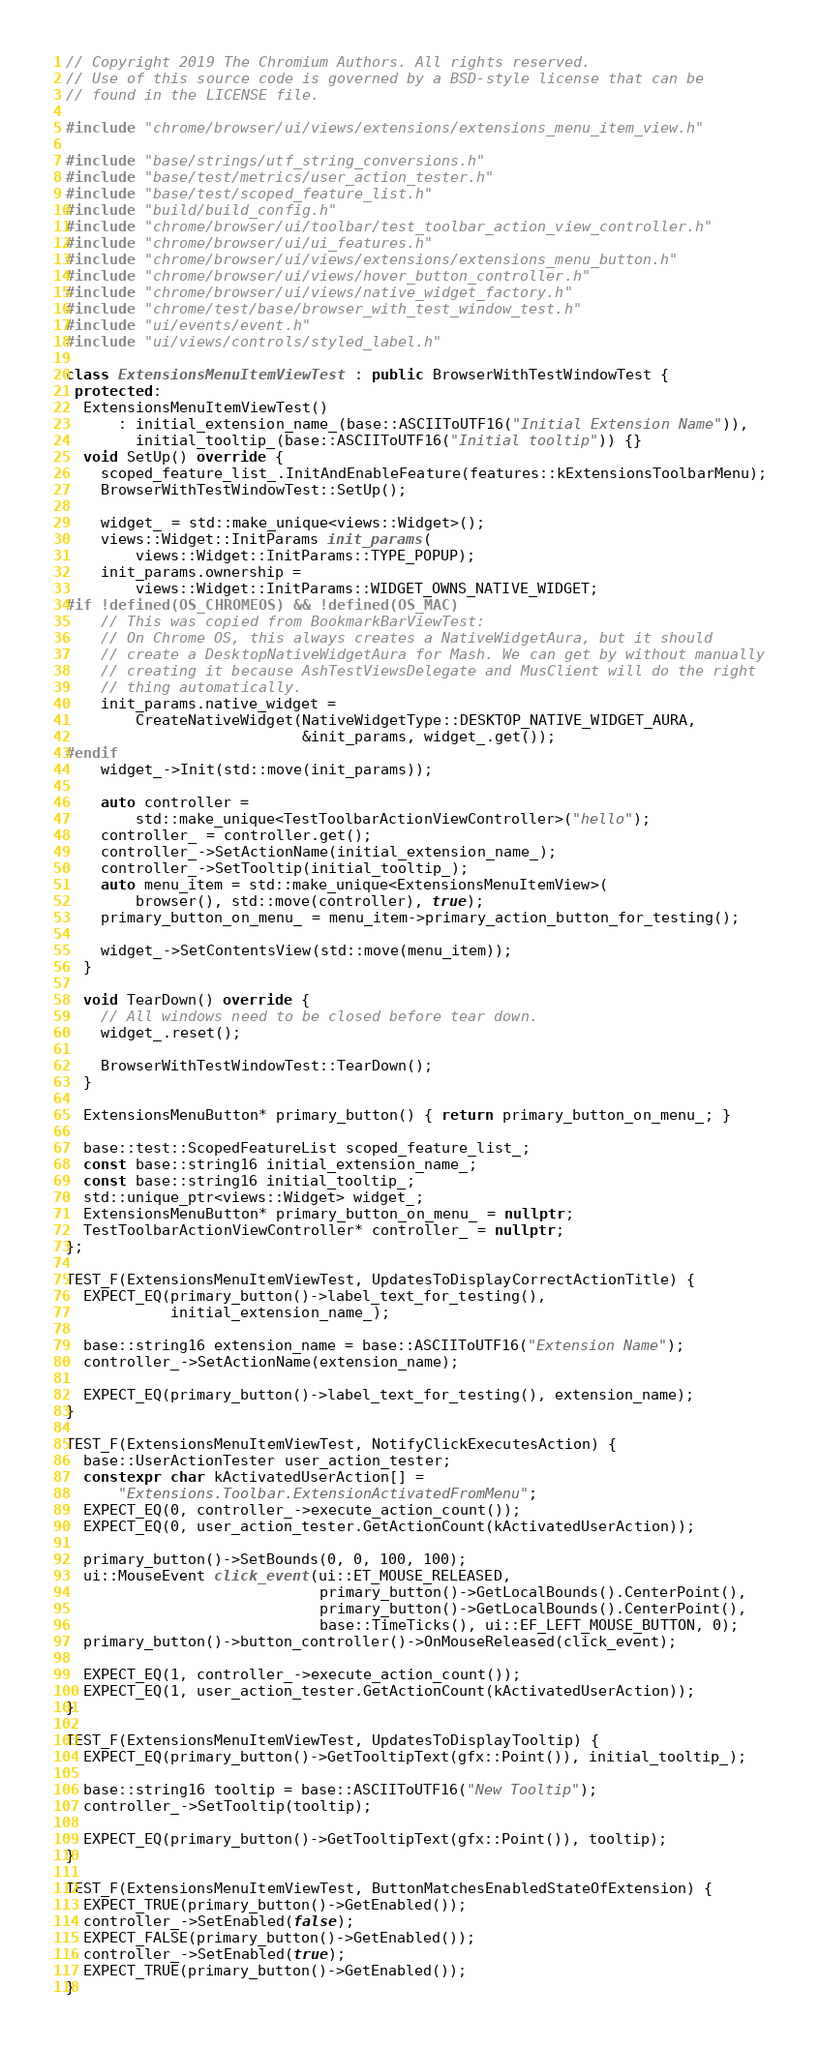<code> <loc_0><loc_0><loc_500><loc_500><_C++_>// Copyright 2019 The Chromium Authors. All rights reserved.
// Use of this source code is governed by a BSD-style license that can be
// found in the LICENSE file.

#include "chrome/browser/ui/views/extensions/extensions_menu_item_view.h"

#include "base/strings/utf_string_conversions.h"
#include "base/test/metrics/user_action_tester.h"
#include "base/test/scoped_feature_list.h"
#include "build/build_config.h"
#include "chrome/browser/ui/toolbar/test_toolbar_action_view_controller.h"
#include "chrome/browser/ui/ui_features.h"
#include "chrome/browser/ui/views/extensions/extensions_menu_button.h"
#include "chrome/browser/ui/views/hover_button_controller.h"
#include "chrome/browser/ui/views/native_widget_factory.h"
#include "chrome/test/base/browser_with_test_window_test.h"
#include "ui/events/event.h"
#include "ui/views/controls/styled_label.h"

class ExtensionsMenuItemViewTest : public BrowserWithTestWindowTest {
 protected:
  ExtensionsMenuItemViewTest()
      : initial_extension_name_(base::ASCIIToUTF16("Initial Extension Name")),
        initial_tooltip_(base::ASCIIToUTF16("Initial tooltip")) {}
  void SetUp() override {
    scoped_feature_list_.InitAndEnableFeature(features::kExtensionsToolbarMenu);
    BrowserWithTestWindowTest::SetUp();

    widget_ = std::make_unique<views::Widget>();
    views::Widget::InitParams init_params(
        views::Widget::InitParams::TYPE_POPUP);
    init_params.ownership =
        views::Widget::InitParams::WIDGET_OWNS_NATIVE_WIDGET;
#if !defined(OS_CHROMEOS) && !defined(OS_MAC)
    // This was copied from BookmarkBarViewTest:
    // On Chrome OS, this always creates a NativeWidgetAura, but it should
    // create a DesktopNativeWidgetAura for Mash. We can get by without manually
    // creating it because AshTestViewsDelegate and MusClient will do the right
    // thing automatically.
    init_params.native_widget =
        CreateNativeWidget(NativeWidgetType::DESKTOP_NATIVE_WIDGET_AURA,
                           &init_params, widget_.get());
#endif
    widget_->Init(std::move(init_params));

    auto controller =
        std::make_unique<TestToolbarActionViewController>("hello");
    controller_ = controller.get();
    controller_->SetActionName(initial_extension_name_);
    controller_->SetTooltip(initial_tooltip_);
    auto menu_item = std::make_unique<ExtensionsMenuItemView>(
        browser(), std::move(controller), true);
    primary_button_on_menu_ = menu_item->primary_action_button_for_testing();

    widget_->SetContentsView(std::move(menu_item));
  }

  void TearDown() override {
    // All windows need to be closed before tear down.
    widget_.reset();

    BrowserWithTestWindowTest::TearDown();
  }

  ExtensionsMenuButton* primary_button() { return primary_button_on_menu_; }

  base::test::ScopedFeatureList scoped_feature_list_;
  const base::string16 initial_extension_name_;
  const base::string16 initial_tooltip_;
  std::unique_ptr<views::Widget> widget_;
  ExtensionsMenuButton* primary_button_on_menu_ = nullptr;
  TestToolbarActionViewController* controller_ = nullptr;
};

TEST_F(ExtensionsMenuItemViewTest, UpdatesToDisplayCorrectActionTitle) {
  EXPECT_EQ(primary_button()->label_text_for_testing(),
            initial_extension_name_);

  base::string16 extension_name = base::ASCIIToUTF16("Extension Name");
  controller_->SetActionName(extension_name);

  EXPECT_EQ(primary_button()->label_text_for_testing(), extension_name);
}

TEST_F(ExtensionsMenuItemViewTest, NotifyClickExecutesAction) {
  base::UserActionTester user_action_tester;
  constexpr char kActivatedUserAction[] =
      "Extensions.Toolbar.ExtensionActivatedFromMenu";
  EXPECT_EQ(0, controller_->execute_action_count());
  EXPECT_EQ(0, user_action_tester.GetActionCount(kActivatedUserAction));

  primary_button()->SetBounds(0, 0, 100, 100);
  ui::MouseEvent click_event(ui::ET_MOUSE_RELEASED,
                             primary_button()->GetLocalBounds().CenterPoint(),
                             primary_button()->GetLocalBounds().CenterPoint(),
                             base::TimeTicks(), ui::EF_LEFT_MOUSE_BUTTON, 0);
  primary_button()->button_controller()->OnMouseReleased(click_event);

  EXPECT_EQ(1, controller_->execute_action_count());
  EXPECT_EQ(1, user_action_tester.GetActionCount(kActivatedUserAction));
}

TEST_F(ExtensionsMenuItemViewTest, UpdatesToDisplayTooltip) {
  EXPECT_EQ(primary_button()->GetTooltipText(gfx::Point()), initial_tooltip_);

  base::string16 tooltip = base::ASCIIToUTF16("New Tooltip");
  controller_->SetTooltip(tooltip);

  EXPECT_EQ(primary_button()->GetTooltipText(gfx::Point()), tooltip);
}

TEST_F(ExtensionsMenuItemViewTest, ButtonMatchesEnabledStateOfExtension) {
  EXPECT_TRUE(primary_button()->GetEnabled());
  controller_->SetEnabled(false);
  EXPECT_FALSE(primary_button()->GetEnabled());
  controller_->SetEnabled(true);
  EXPECT_TRUE(primary_button()->GetEnabled());
}
</code> 